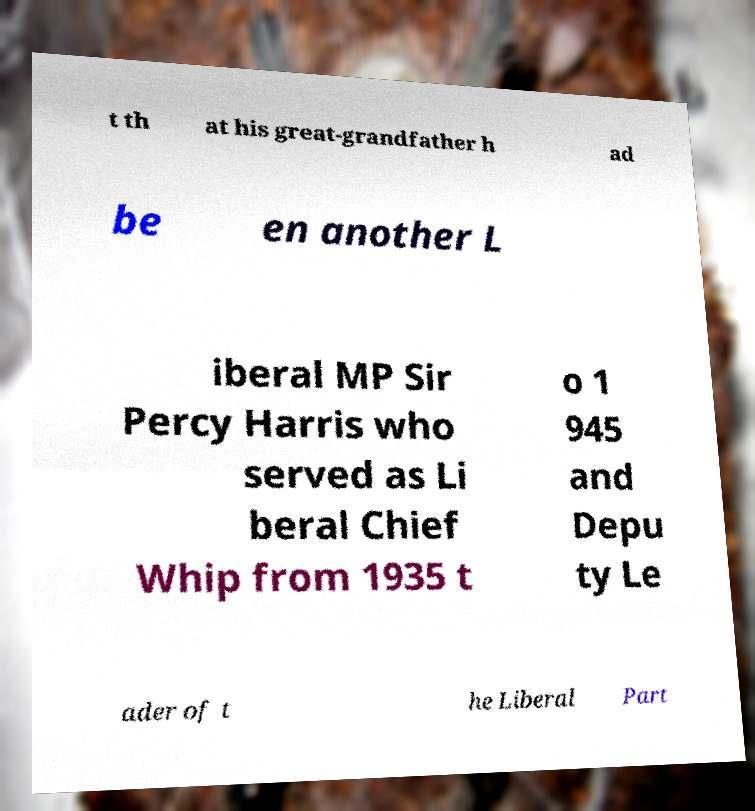Could you extract and type out the text from this image? t th at his great-grandfather h ad be en another L iberal MP Sir Percy Harris who served as Li beral Chief Whip from 1935 t o 1 945 and Depu ty Le ader of t he Liberal Part 